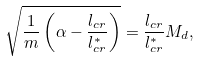Convert formula to latex. <formula><loc_0><loc_0><loc_500><loc_500>\sqrt { \frac { 1 } { m } \left ( \alpha - \frac { l _ { c r } } { l _ { c r } ^ { * } } \right ) } = \frac { l _ { c r } } { l _ { c r } ^ { * } } M _ { d } ,</formula> 